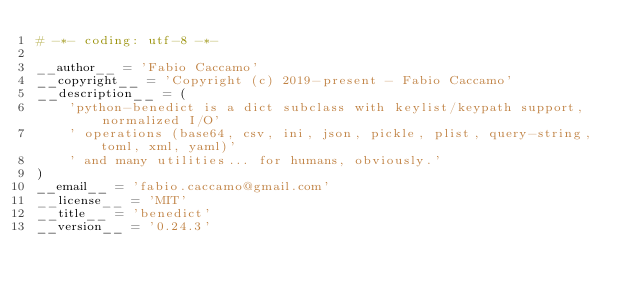<code> <loc_0><loc_0><loc_500><loc_500><_Python_># -*- coding: utf-8 -*-

__author__ = 'Fabio Caccamo'
__copyright__ = 'Copyright (c) 2019-present - Fabio Caccamo'
__description__ = (
    'python-benedict is a dict subclass with keylist/keypath support, normalized I/O'
    ' operations (base64, csv, ini, json, pickle, plist, query-string, toml, xml, yaml)'
    ' and many utilities... for humans, obviously.'
)
__email__ = 'fabio.caccamo@gmail.com'
__license__ = 'MIT'
__title__ = 'benedict'
__version__ = '0.24.3'
</code> 